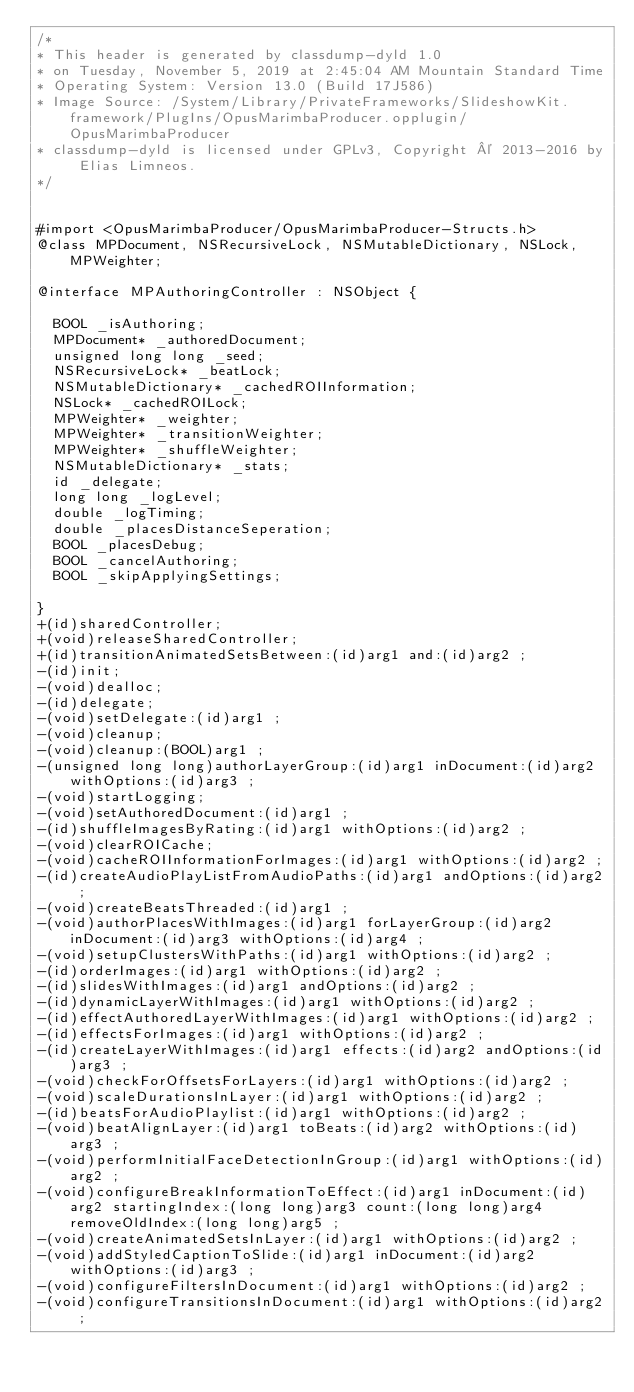<code> <loc_0><loc_0><loc_500><loc_500><_C_>/*
* This header is generated by classdump-dyld 1.0
* on Tuesday, November 5, 2019 at 2:45:04 AM Mountain Standard Time
* Operating System: Version 13.0 (Build 17J586)
* Image Source: /System/Library/PrivateFrameworks/SlideshowKit.framework/PlugIns/OpusMarimbaProducer.opplugin/OpusMarimbaProducer
* classdump-dyld is licensed under GPLv3, Copyright © 2013-2016 by Elias Limneos.
*/


#import <OpusMarimbaProducer/OpusMarimbaProducer-Structs.h>
@class MPDocument, NSRecursiveLock, NSMutableDictionary, NSLock, MPWeighter;

@interface MPAuthoringController : NSObject {

	BOOL _isAuthoring;
	MPDocument* _authoredDocument;
	unsigned long long _seed;
	NSRecursiveLock* _beatLock;
	NSMutableDictionary* _cachedROIInformation;
	NSLock* _cachedROILock;
	MPWeighter* _weighter;
	MPWeighter* _transitionWeighter;
	MPWeighter* _shuffleWeighter;
	NSMutableDictionary* _stats;
	id _delegate;
	long long _logLevel;
	double _logTiming;
	double _placesDistanceSeperation;
	BOOL _placesDebug;
	BOOL _cancelAuthoring;
	BOOL _skipApplyingSettings;

}
+(id)sharedController;
+(void)releaseSharedController;
+(id)transitionAnimatedSetsBetween:(id)arg1 and:(id)arg2 ;
-(id)init;
-(void)dealloc;
-(id)delegate;
-(void)setDelegate:(id)arg1 ;
-(void)cleanup;
-(void)cleanup:(BOOL)arg1 ;
-(unsigned long long)authorLayerGroup:(id)arg1 inDocument:(id)arg2 withOptions:(id)arg3 ;
-(void)startLogging;
-(void)setAuthoredDocument:(id)arg1 ;
-(id)shuffleImagesByRating:(id)arg1 withOptions:(id)arg2 ;
-(void)clearROICache;
-(void)cacheROIInformationForImages:(id)arg1 withOptions:(id)arg2 ;
-(id)createAudioPlayListFromAudioPaths:(id)arg1 andOptions:(id)arg2 ;
-(void)createBeatsThreaded:(id)arg1 ;
-(void)authorPlacesWithImages:(id)arg1 forLayerGroup:(id)arg2 inDocument:(id)arg3 withOptions:(id)arg4 ;
-(void)setupClustersWithPaths:(id)arg1 withOptions:(id)arg2 ;
-(id)orderImages:(id)arg1 withOptions:(id)arg2 ;
-(id)slidesWithImages:(id)arg1 andOptions:(id)arg2 ;
-(id)dynamicLayerWithImages:(id)arg1 withOptions:(id)arg2 ;
-(id)effectAuthoredLayerWithImages:(id)arg1 withOptions:(id)arg2 ;
-(id)effectsForImages:(id)arg1 withOptions:(id)arg2 ;
-(id)createLayerWithImages:(id)arg1 effects:(id)arg2 andOptions:(id)arg3 ;
-(void)checkForOffsetsForLayers:(id)arg1 withOptions:(id)arg2 ;
-(void)scaleDurationsInLayer:(id)arg1 withOptions:(id)arg2 ;
-(id)beatsForAudioPlaylist:(id)arg1 withOptions:(id)arg2 ;
-(void)beatAlignLayer:(id)arg1 toBeats:(id)arg2 withOptions:(id)arg3 ;
-(void)performInitialFaceDetectionInGroup:(id)arg1 withOptions:(id)arg2 ;
-(void)configureBreakInformationToEffect:(id)arg1 inDocument:(id)arg2 startingIndex:(long long)arg3 count:(long long)arg4 removeOldIndex:(long long)arg5 ;
-(void)createAnimatedSetsInLayer:(id)arg1 withOptions:(id)arg2 ;
-(void)addStyledCaptionToSlide:(id)arg1 inDocument:(id)arg2 withOptions:(id)arg3 ;
-(void)configureFiltersInDocument:(id)arg1 withOptions:(id)arg2 ;
-(void)configureTransitionsInDocument:(id)arg1 withOptions:(id)arg2 ;</code> 